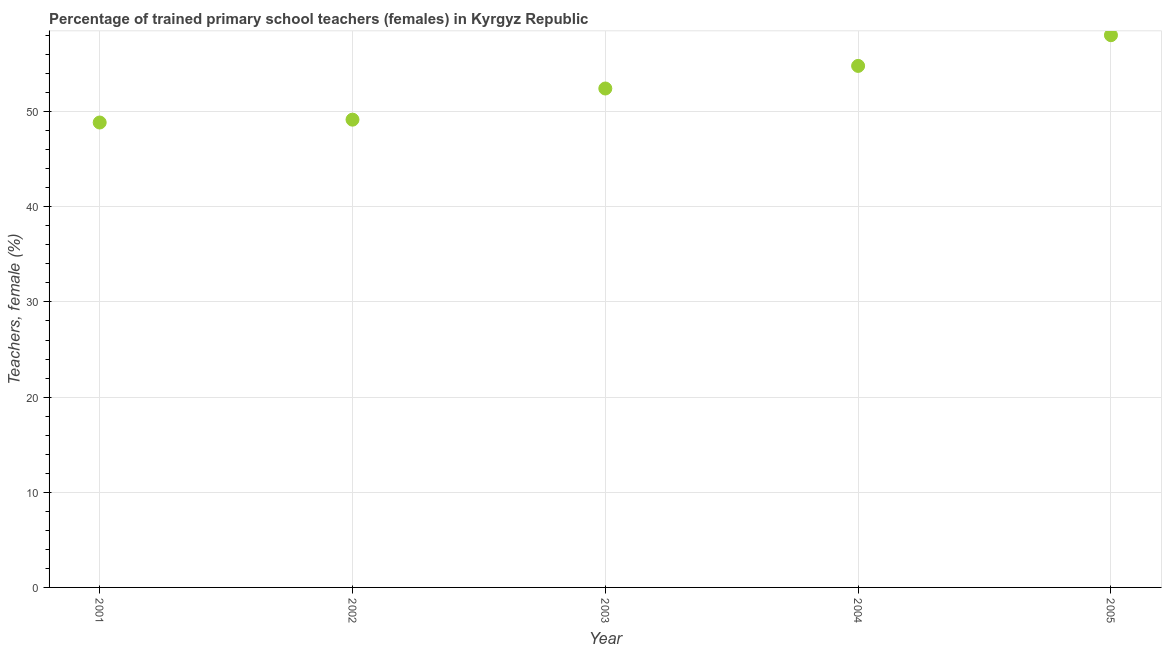What is the percentage of trained female teachers in 2001?
Offer a very short reply. 48.85. Across all years, what is the maximum percentage of trained female teachers?
Your response must be concise. 58.03. Across all years, what is the minimum percentage of trained female teachers?
Provide a succinct answer. 48.85. What is the sum of the percentage of trained female teachers?
Your response must be concise. 263.27. What is the difference between the percentage of trained female teachers in 2002 and 2004?
Your response must be concise. -5.65. What is the average percentage of trained female teachers per year?
Keep it short and to the point. 52.65. What is the median percentage of trained female teachers?
Make the answer very short. 52.43. In how many years, is the percentage of trained female teachers greater than 28 %?
Provide a short and direct response. 5. Do a majority of the years between 2003 and 2002 (inclusive) have percentage of trained female teachers greater than 28 %?
Provide a succinct answer. No. What is the ratio of the percentage of trained female teachers in 2003 to that in 2004?
Your answer should be very brief. 0.96. What is the difference between the highest and the second highest percentage of trained female teachers?
Make the answer very short. 3.23. What is the difference between the highest and the lowest percentage of trained female teachers?
Your response must be concise. 9.18. What is the difference between two consecutive major ticks on the Y-axis?
Keep it short and to the point. 10. Does the graph contain any zero values?
Make the answer very short. No. Does the graph contain grids?
Ensure brevity in your answer.  Yes. What is the title of the graph?
Offer a very short reply. Percentage of trained primary school teachers (females) in Kyrgyz Republic. What is the label or title of the X-axis?
Your response must be concise. Year. What is the label or title of the Y-axis?
Your answer should be compact. Teachers, female (%). What is the Teachers, female (%) in 2001?
Provide a succinct answer. 48.85. What is the Teachers, female (%) in 2002?
Offer a terse response. 49.16. What is the Teachers, female (%) in 2003?
Provide a short and direct response. 52.43. What is the Teachers, female (%) in 2004?
Offer a terse response. 54.8. What is the Teachers, female (%) in 2005?
Keep it short and to the point. 58.03. What is the difference between the Teachers, female (%) in 2001 and 2002?
Your answer should be compact. -0.3. What is the difference between the Teachers, female (%) in 2001 and 2003?
Your answer should be compact. -3.57. What is the difference between the Teachers, female (%) in 2001 and 2004?
Ensure brevity in your answer.  -5.95. What is the difference between the Teachers, female (%) in 2001 and 2005?
Ensure brevity in your answer.  -9.18. What is the difference between the Teachers, female (%) in 2002 and 2003?
Offer a very short reply. -3.27. What is the difference between the Teachers, female (%) in 2002 and 2004?
Your answer should be compact. -5.65. What is the difference between the Teachers, female (%) in 2002 and 2005?
Your response must be concise. -8.88. What is the difference between the Teachers, female (%) in 2003 and 2004?
Provide a short and direct response. -2.37. What is the difference between the Teachers, female (%) in 2003 and 2005?
Your answer should be very brief. -5.6. What is the difference between the Teachers, female (%) in 2004 and 2005?
Provide a short and direct response. -3.23. What is the ratio of the Teachers, female (%) in 2001 to that in 2003?
Keep it short and to the point. 0.93. What is the ratio of the Teachers, female (%) in 2001 to that in 2004?
Make the answer very short. 0.89. What is the ratio of the Teachers, female (%) in 2001 to that in 2005?
Make the answer very short. 0.84. What is the ratio of the Teachers, female (%) in 2002 to that in 2003?
Your answer should be very brief. 0.94. What is the ratio of the Teachers, female (%) in 2002 to that in 2004?
Offer a very short reply. 0.9. What is the ratio of the Teachers, female (%) in 2002 to that in 2005?
Ensure brevity in your answer.  0.85. What is the ratio of the Teachers, female (%) in 2003 to that in 2005?
Your answer should be compact. 0.9. What is the ratio of the Teachers, female (%) in 2004 to that in 2005?
Give a very brief answer. 0.94. 